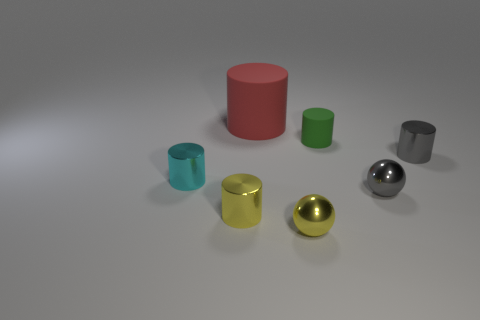Do the tiny rubber object and the big thing have the same color?
Offer a very short reply. No. There is a small yellow thing right of the yellow thing on the left side of the big red matte thing; what is it made of?
Make the answer very short. Metal. How big is the yellow shiny cylinder?
Offer a very short reply. Small. What size is the gray sphere that is made of the same material as the small cyan object?
Your answer should be very brief. Small. There is a metal sphere on the right side of the green thing; is it the same size as the green rubber cylinder?
Offer a very short reply. Yes. The tiny gray thing to the left of the shiny cylinder that is on the right side of the tiny cylinder behind the gray shiny cylinder is what shape?
Provide a short and direct response. Sphere. How many things are either small green cylinders or matte objects that are in front of the red rubber thing?
Give a very brief answer. 1. What is the size of the metal cylinder in front of the cyan cylinder?
Make the answer very short. Small. Is the small cyan object made of the same material as the yellow thing to the right of the red matte thing?
Ensure brevity in your answer.  Yes. What number of cyan things are in front of the matte thing behind the matte cylinder that is in front of the red object?
Ensure brevity in your answer.  1. 